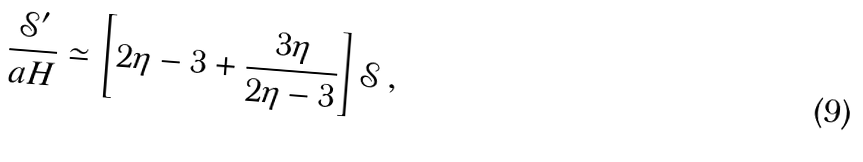Convert formula to latex. <formula><loc_0><loc_0><loc_500><loc_500>\frac { { \mathcal { S } } ^ { \prime } } { a H } \simeq \left [ 2 \eta - 3 + \frac { 3 \eta } { 2 \eta - 3 } \right ] { \mathcal { S } } \, ,</formula> 